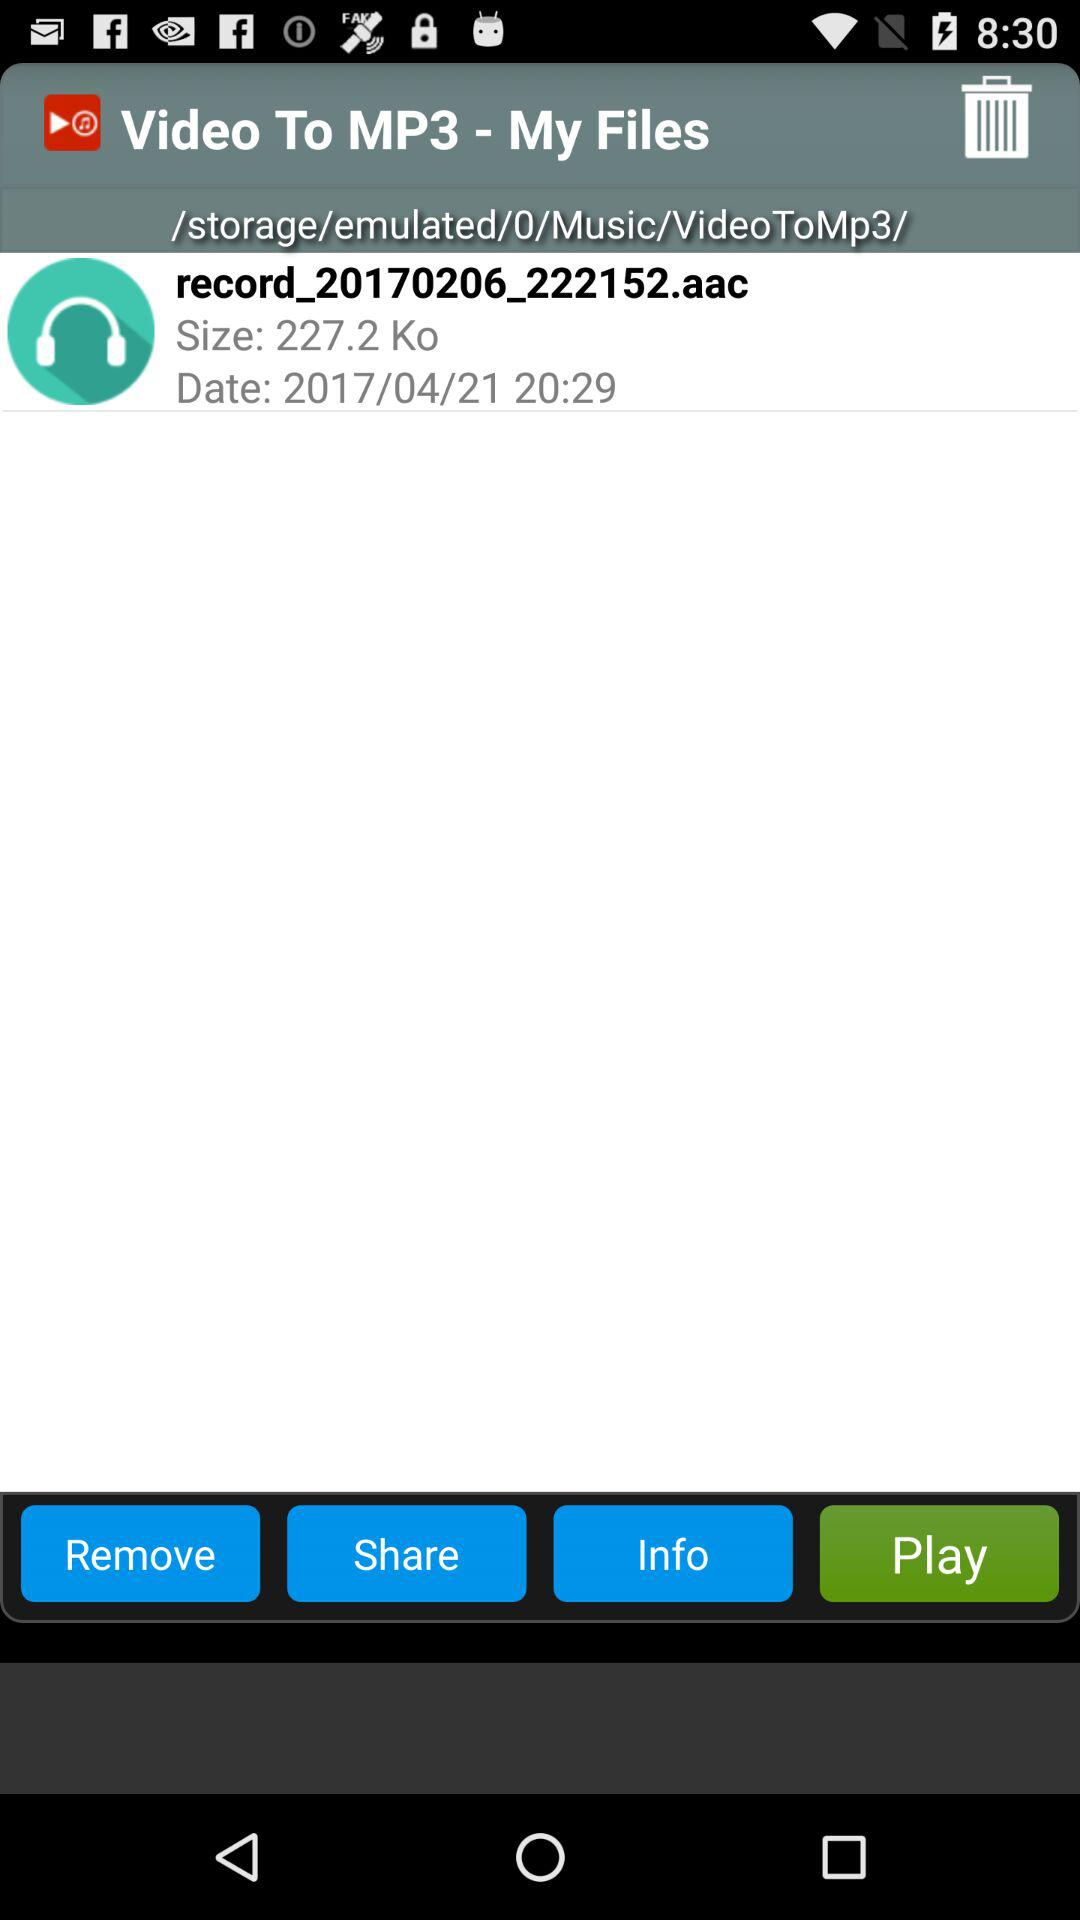What is the size of the recording? The size of the recording is 227.2 Ko. 